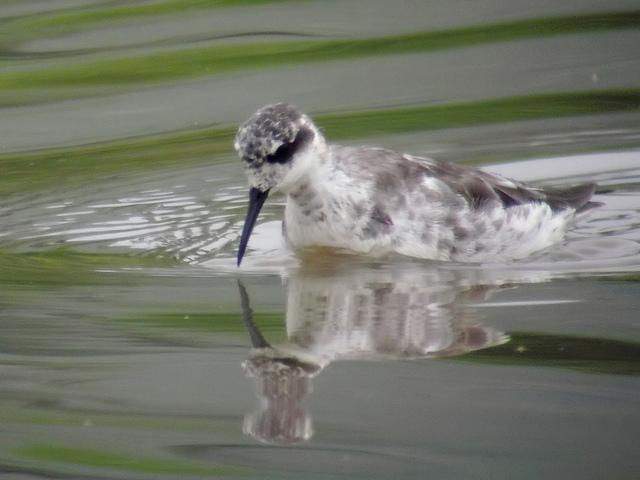How many birds are there?
Give a very brief answer. 1. How many chairs are in this room?
Give a very brief answer. 0. 